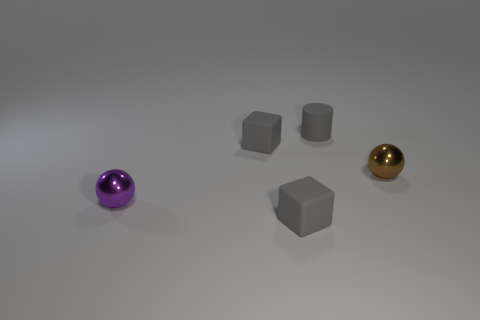Add 1 brown objects. How many objects exist? 6 Subtract all cylinders. How many objects are left? 4 Subtract 0 blue blocks. How many objects are left? 5 Subtract all rubber blocks. Subtract all tiny gray rubber objects. How many objects are left? 0 Add 2 tiny gray rubber cubes. How many tiny gray rubber cubes are left? 4 Add 5 blocks. How many blocks exist? 7 